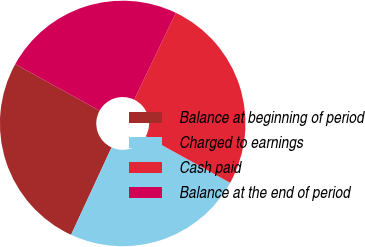Convert chart. <chart><loc_0><loc_0><loc_500><loc_500><pie_chart><fcel>Balance at beginning of period<fcel>Charged to earnings<fcel>Cash paid<fcel>Balance at the end of period<nl><fcel>26.12%<fcel>23.88%<fcel>25.9%<fcel>24.1%<nl></chart> 